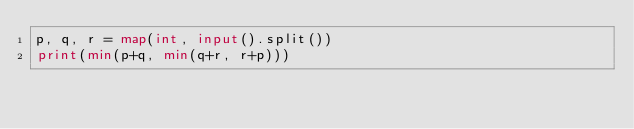Convert code to text. <code><loc_0><loc_0><loc_500><loc_500><_Python_>p, q, r = map(int, input().split())
print(min(p+q, min(q+r, r+p)))</code> 